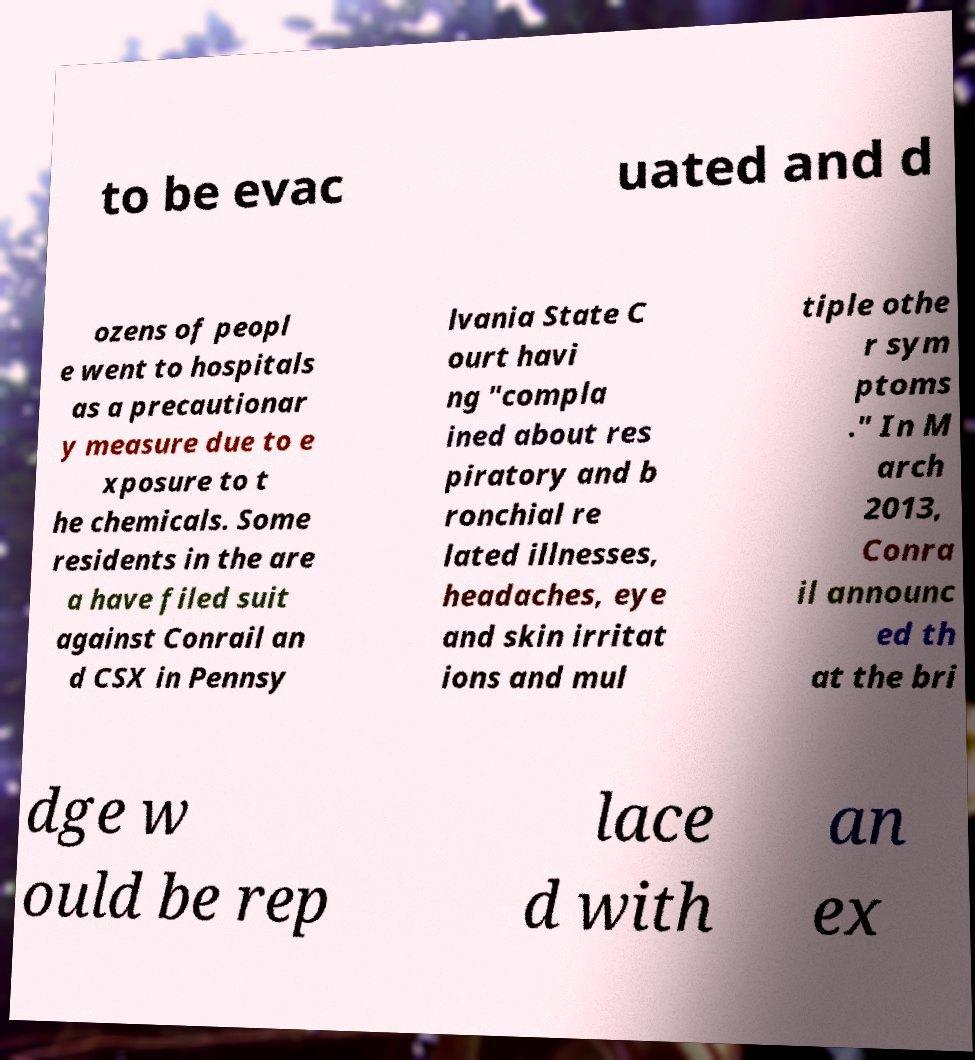I need the written content from this picture converted into text. Can you do that? to be evac uated and d ozens of peopl e went to hospitals as a precautionar y measure due to e xposure to t he chemicals. Some residents in the are a have filed suit against Conrail an d CSX in Pennsy lvania State C ourt havi ng "compla ined about res piratory and b ronchial re lated illnesses, headaches, eye and skin irritat ions and mul tiple othe r sym ptoms ." In M arch 2013, Conra il announc ed th at the bri dge w ould be rep lace d with an ex 